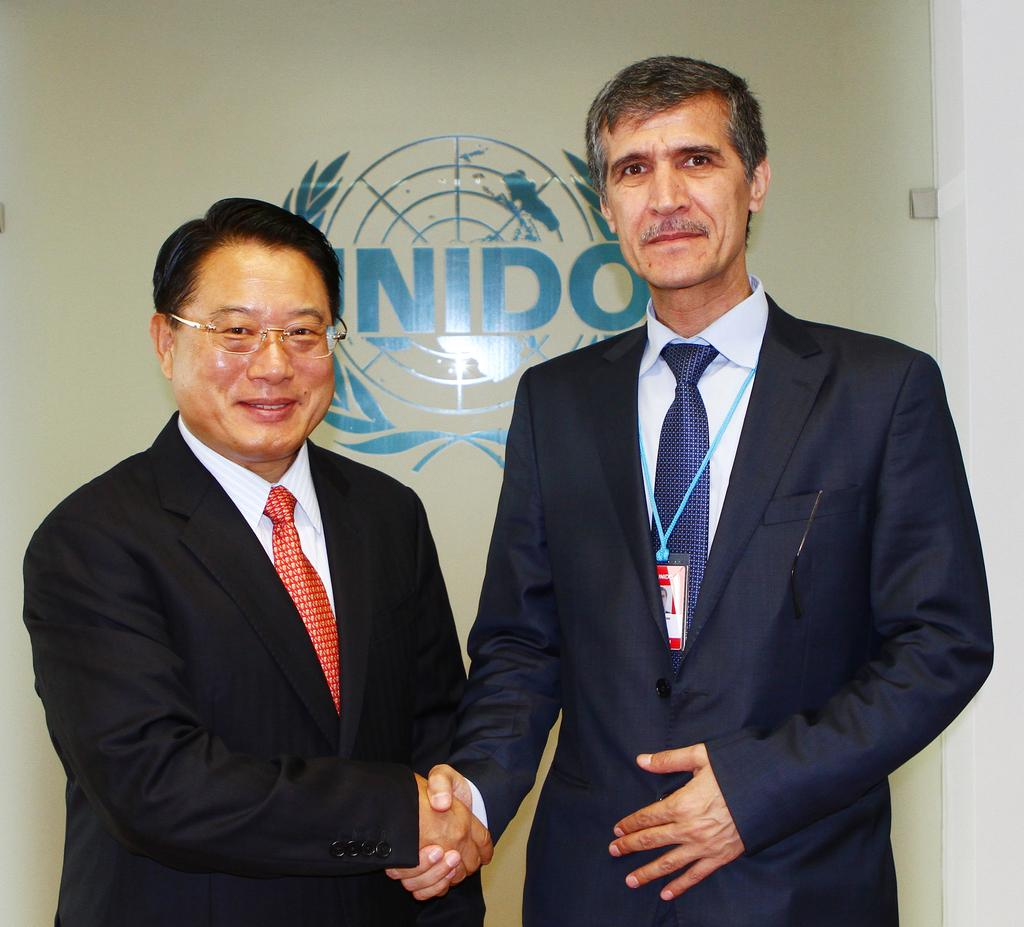How many people are in the image? There are two people standing in the center of the image. What are the two people doing? The two people are shaking hands. What can be seen in the background of the image? There is a wall in the background of the image. What type of road can be seen in the image? There is no road visible in the image; it only shows two people shaking hands with a wall in the background. 